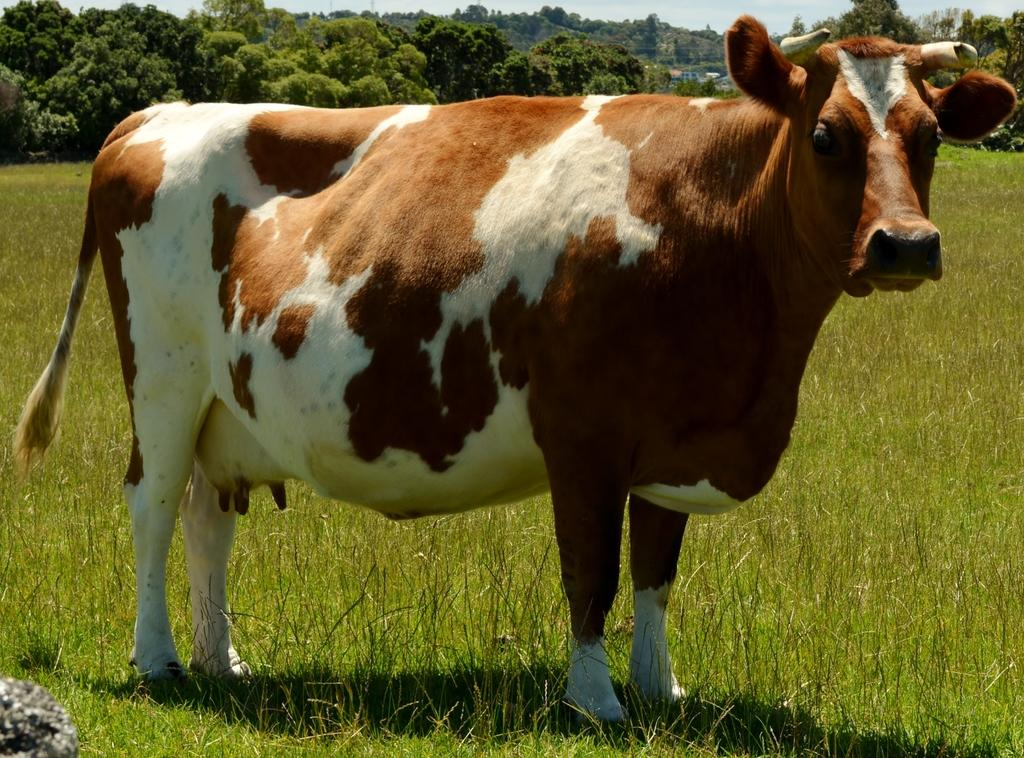What animal is in the image? There is a cow in the image. What is the cow standing on? The cow is standing on the grass. What can be seen in the background of the image? There are trees visible in the background of the image. What is visible at the top of the image? The sky is visible at the top of the image. What type of vegetation is present at the bottom of the image? Grass is present at the bottom of the image. Can you tell me how many heads of lettuce are visible in the image? There are no heads of lettuce present in the image. Is the cow driving a car in the image? No, the cow is not driving a car in the image; it is standing on the grass. 